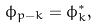<formula> <loc_0><loc_0><loc_500><loc_500>\phi _ { p - k } = \phi _ { k } ^ { * } ,</formula> 